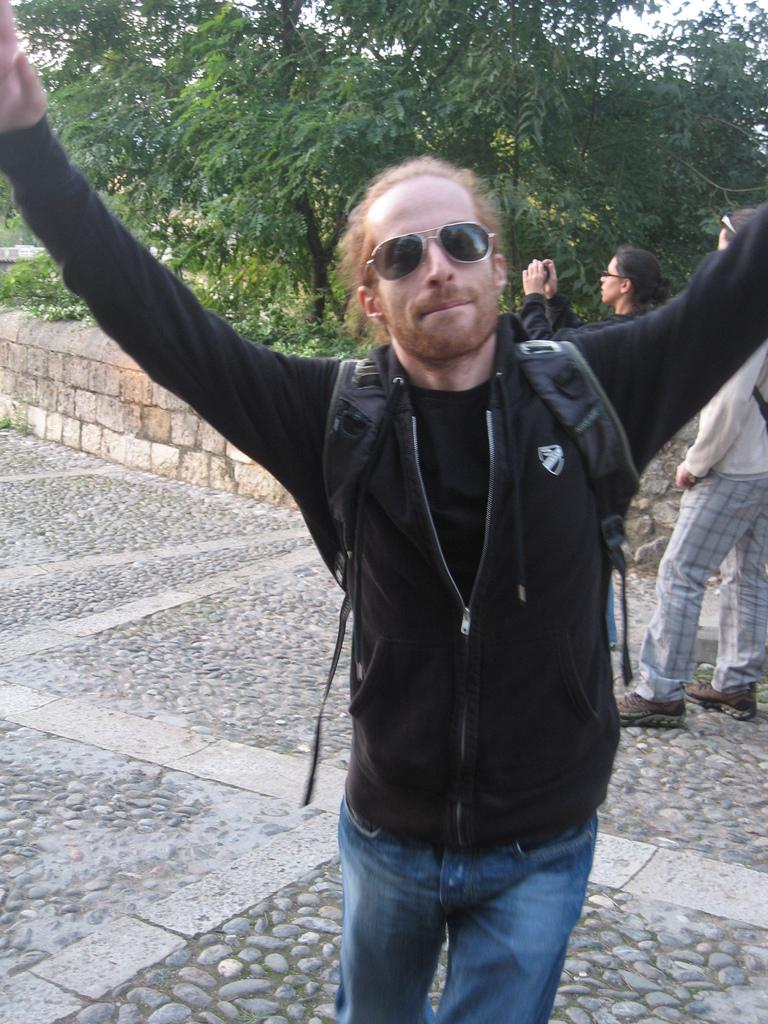How many people are present in the image? There are three people standing in the image. What can be seen behind the people in the image? There is a wall in the image. What type of vegetation is visible in the image? There are trees in the image. What is visible above the people in the image? The sky is visible in the image. What is the man standing in the front wearing? The man standing in the front is wearing a black color jacket. What type of sweater is the committee wearing in the image? There is no committee or sweater present in the image. 